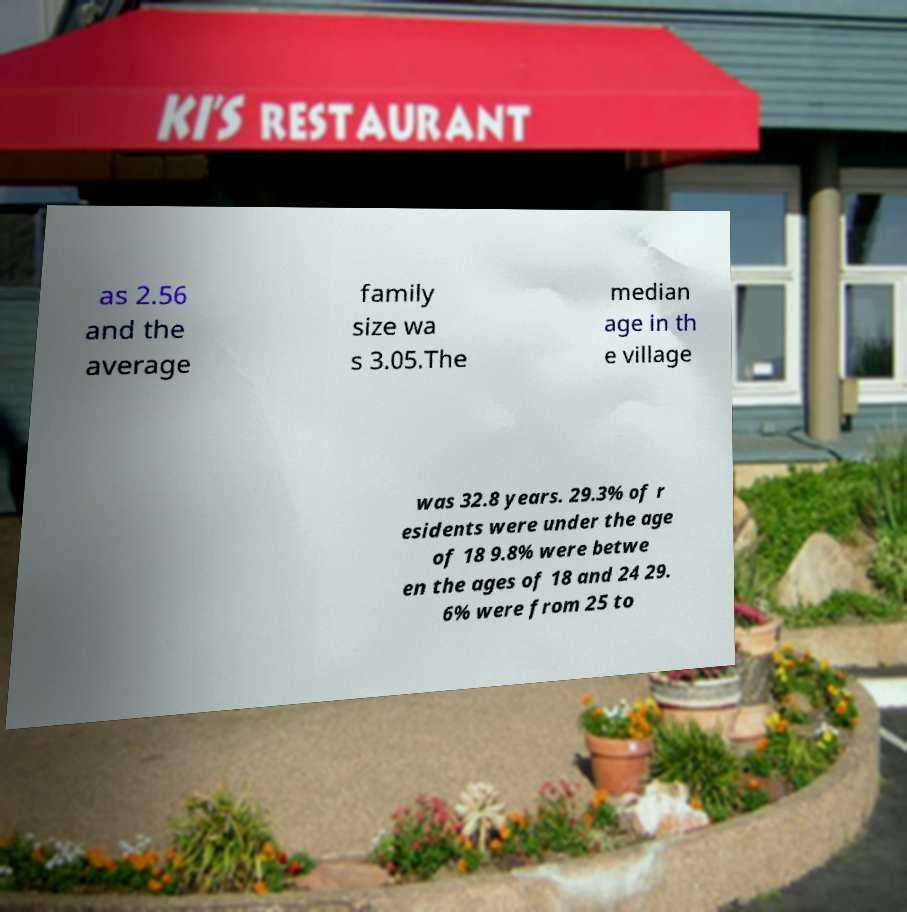Can you read and provide the text displayed in the image?This photo seems to have some interesting text. Can you extract and type it out for me? as 2.56 and the average family size wa s 3.05.The median age in th e village was 32.8 years. 29.3% of r esidents were under the age of 18 9.8% were betwe en the ages of 18 and 24 29. 6% were from 25 to 